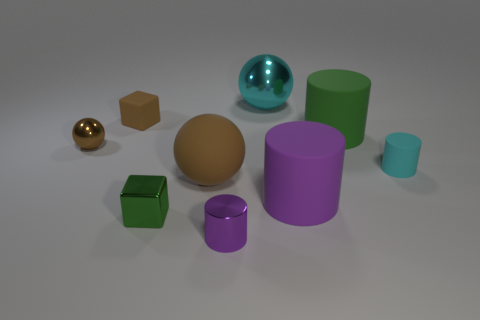How do the different shapes and colors in the image contribute to its aesthetic appeal? The array of geometric shapes, including cylinders, spheres, and cubes, arranged haphazardly, provides a visual feast of 3D forms to appreciate. The color palette, consisting of earthy browns, vibrant purples, greens, and a hint of reflective gold and turquoise, adds depth and intrigue. The contrast of matte and reflective surfaces further enhances the aesthetic, letting the viewer appreciate the interplay of light and texture. 